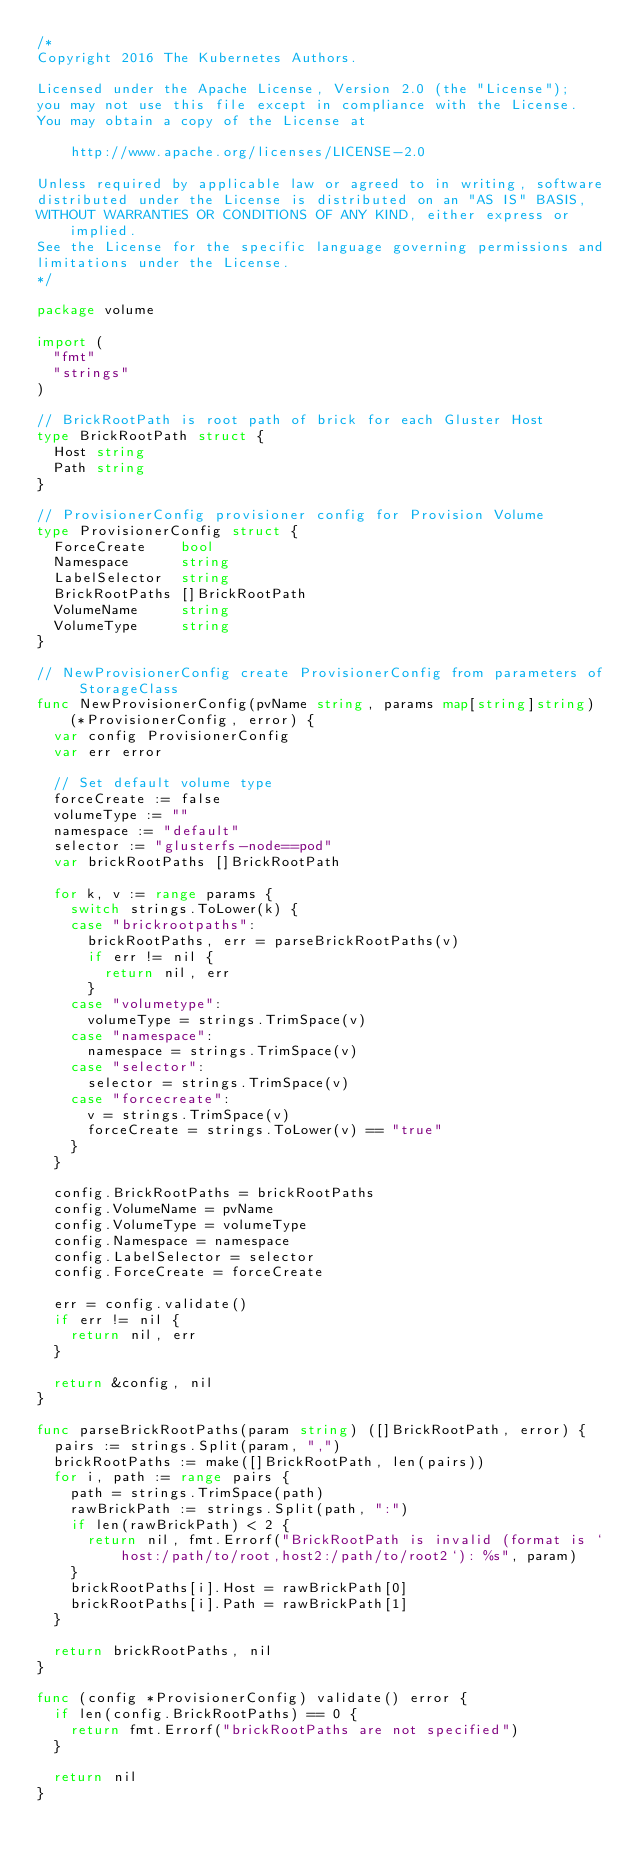Convert code to text. <code><loc_0><loc_0><loc_500><loc_500><_Go_>/*
Copyright 2016 The Kubernetes Authors.

Licensed under the Apache License, Version 2.0 (the "License");
you may not use this file except in compliance with the License.
You may obtain a copy of the License at

    http://www.apache.org/licenses/LICENSE-2.0

Unless required by applicable law or agreed to in writing, software
distributed under the License is distributed on an "AS IS" BASIS,
WITHOUT WARRANTIES OR CONDITIONS OF ANY KIND, either express or implied.
See the License for the specific language governing permissions and
limitations under the License.
*/

package volume

import (
	"fmt"
	"strings"
)

// BrickRootPath is root path of brick for each Gluster Host
type BrickRootPath struct {
	Host string
	Path string
}

// ProvisionerConfig provisioner config for Provision Volume
type ProvisionerConfig struct {
	ForceCreate    bool
	Namespace      string
	LabelSelector  string
	BrickRootPaths []BrickRootPath
	VolumeName     string
	VolumeType     string
}

// NewProvisionerConfig create ProvisionerConfig from parameters of StorageClass
func NewProvisionerConfig(pvName string, params map[string]string) (*ProvisionerConfig, error) {
	var config ProvisionerConfig
	var err error

	// Set default volume type
	forceCreate := false
	volumeType := ""
	namespace := "default"
	selector := "glusterfs-node==pod"
	var brickRootPaths []BrickRootPath

	for k, v := range params {
		switch strings.ToLower(k) {
		case "brickrootpaths":
			brickRootPaths, err = parseBrickRootPaths(v)
			if err != nil {
				return nil, err
			}
		case "volumetype":
			volumeType = strings.TrimSpace(v)
		case "namespace":
			namespace = strings.TrimSpace(v)
		case "selector":
			selector = strings.TrimSpace(v)
		case "forcecreate":
			v = strings.TrimSpace(v)
			forceCreate = strings.ToLower(v) == "true"
		}
	}

	config.BrickRootPaths = brickRootPaths
	config.VolumeName = pvName
	config.VolumeType = volumeType
	config.Namespace = namespace
	config.LabelSelector = selector
	config.ForceCreate = forceCreate

	err = config.validate()
	if err != nil {
		return nil, err
	}

	return &config, nil
}

func parseBrickRootPaths(param string) ([]BrickRootPath, error) {
	pairs := strings.Split(param, ",")
	brickRootPaths := make([]BrickRootPath, len(pairs))
	for i, path := range pairs {
		path = strings.TrimSpace(path)
		rawBrickPath := strings.Split(path, ":")
		if len(rawBrickPath) < 2 {
			return nil, fmt.Errorf("BrickRootPath is invalid (format is `host:/path/to/root,host2:/path/to/root2`): %s", param)
		}
		brickRootPaths[i].Host = rawBrickPath[0]
		brickRootPaths[i].Path = rawBrickPath[1]
	}

	return brickRootPaths, nil
}

func (config *ProvisionerConfig) validate() error {
	if len(config.BrickRootPaths) == 0 {
		return fmt.Errorf("brickRootPaths are not specified")
	}

	return nil
}
</code> 